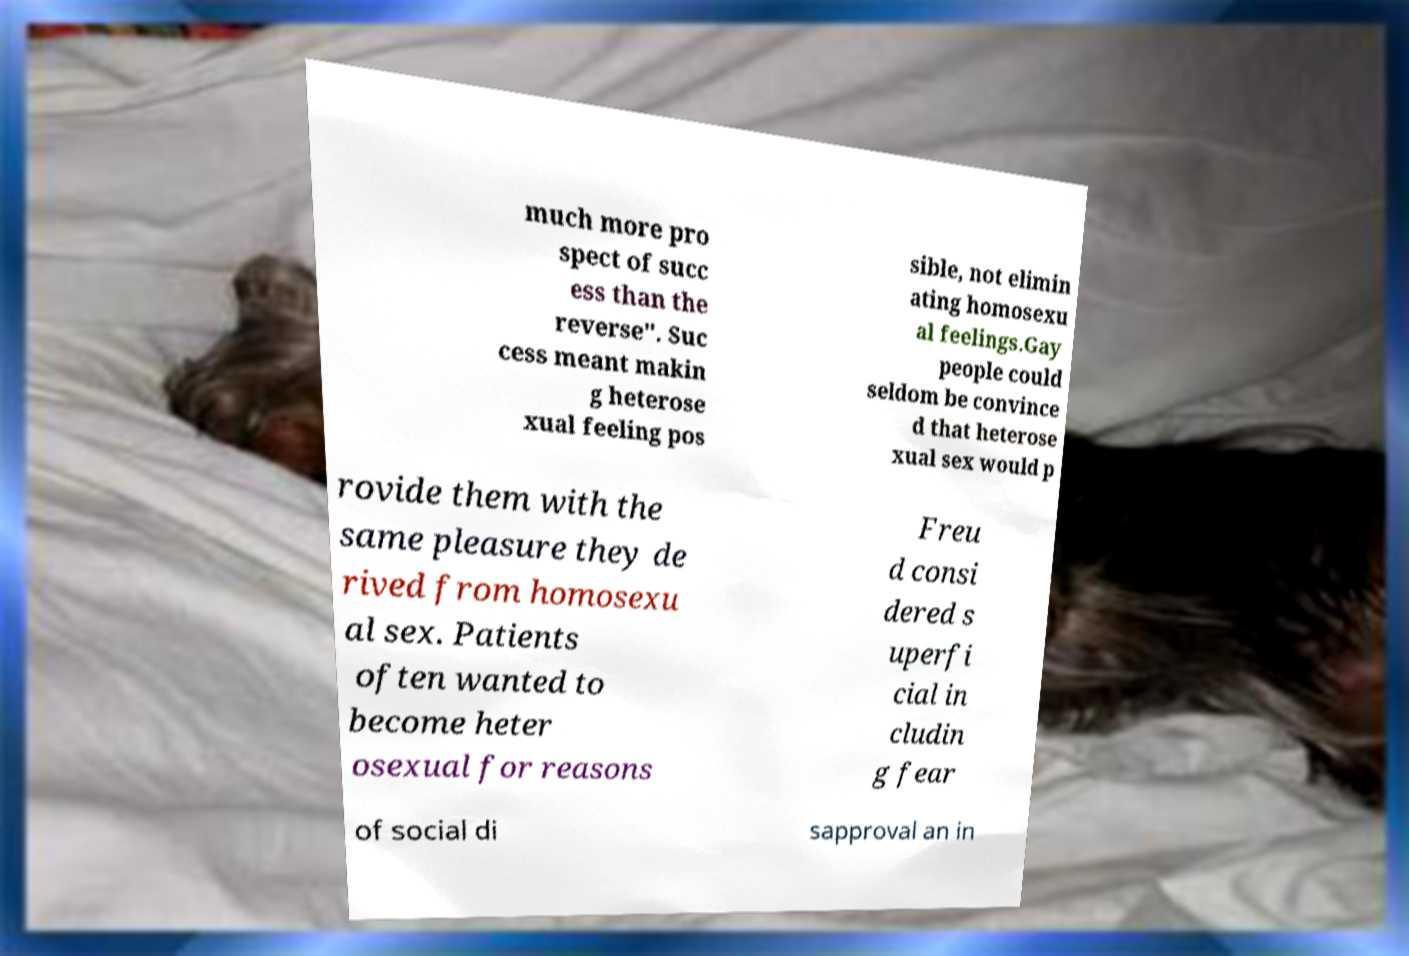Please identify and transcribe the text found in this image. much more pro spect of succ ess than the reverse". Suc cess meant makin g heterose xual feeling pos sible, not elimin ating homosexu al feelings.Gay people could seldom be convince d that heterose xual sex would p rovide them with the same pleasure they de rived from homosexu al sex. Patients often wanted to become heter osexual for reasons Freu d consi dered s uperfi cial in cludin g fear of social di sapproval an in 